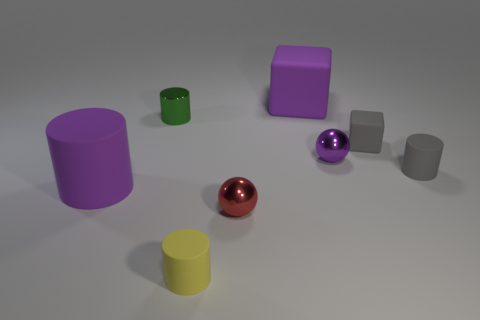The large rubber thing that is the same shape as the small green thing is what color?
Your answer should be very brief. Purple. Is there a tiny red thing that has the same shape as the green metallic object?
Your response must be concise. No. Does the shiny cylinder have the same size as the purple matte thing that is behind the gray cylinder?
Your answer should be very brief. No. How many objects are either objects that are behind the red metal ball or large cubes behind the yellow cylinder?
Provide a short and direct response. 6. Is the number of tiny purple objects behind the large cube greater than the number of purple metal things?
Your response must be concise. No. How many red shiny spheres have the same size as the gray cylinder?
Provide a short and direct response. 1. There is a green object behind the small purple metallic object; is it the same size as the rubber cylinder in front of the big rubber cylinder?
Offer a very short reply. Yes. What size is the matte cylinder on the right side of the small yellow matte object?
Ensure brevity in your answer.  Small. There is a block on the right side of the small metallic ball that is behind the red metallic ball; what is its size?
Make the answer very short. Small. There is a green cylinder that is the same size as the purple sphere; what is its material?
Keep it short and to the point. Metal. 